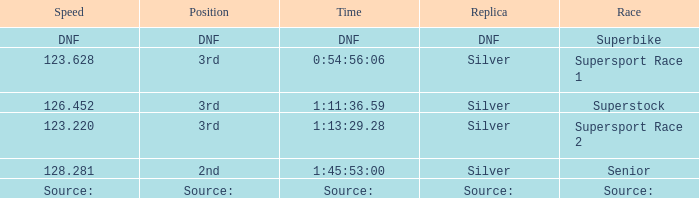Which position has a time of 1:45:53:00? 2nd. Help me parse the entirety of this table. {'header': ['Speed', 'Position', 'Time', 'Replica', 'Race'], 'rows': [['DNF', 'DNF', 'DNF', 'DNF', 'Superbike'], ['123.628', '3rd', '0:54:56:06', 'Silver', 'Supersport Race 1'], ['126.452', '3rd', '1:11:36.59', 'Silver', 'Superstock'], ['123.220', '3rd', '1:13:29.28', 'Silver', 'Supersport Race 2'], ['128.281', '2nd', '1:45:53:00', 'Silver', 'Senior'], ['Source:', 'Source:', 'Source:', 'Source:', 'Source:']]} 